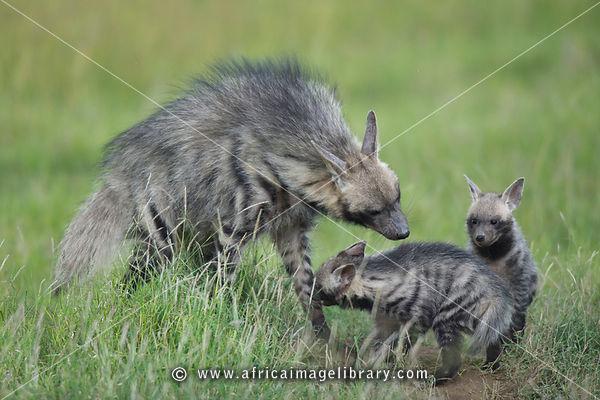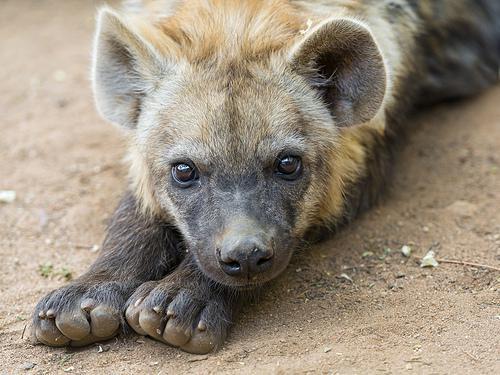The first image is the image on the left, the second image is the image on the right. For the images displayed, is the sentence "The right image contains at least two hyenas." factually correct? Answer yes or no. No. The first image is the image on the left, the second image is the image on the right. Evaluate the accuracy of this statement regarding the images: "In the left image, we have a mother and her pups.". Is it true? Answer yes or no. Yes. 